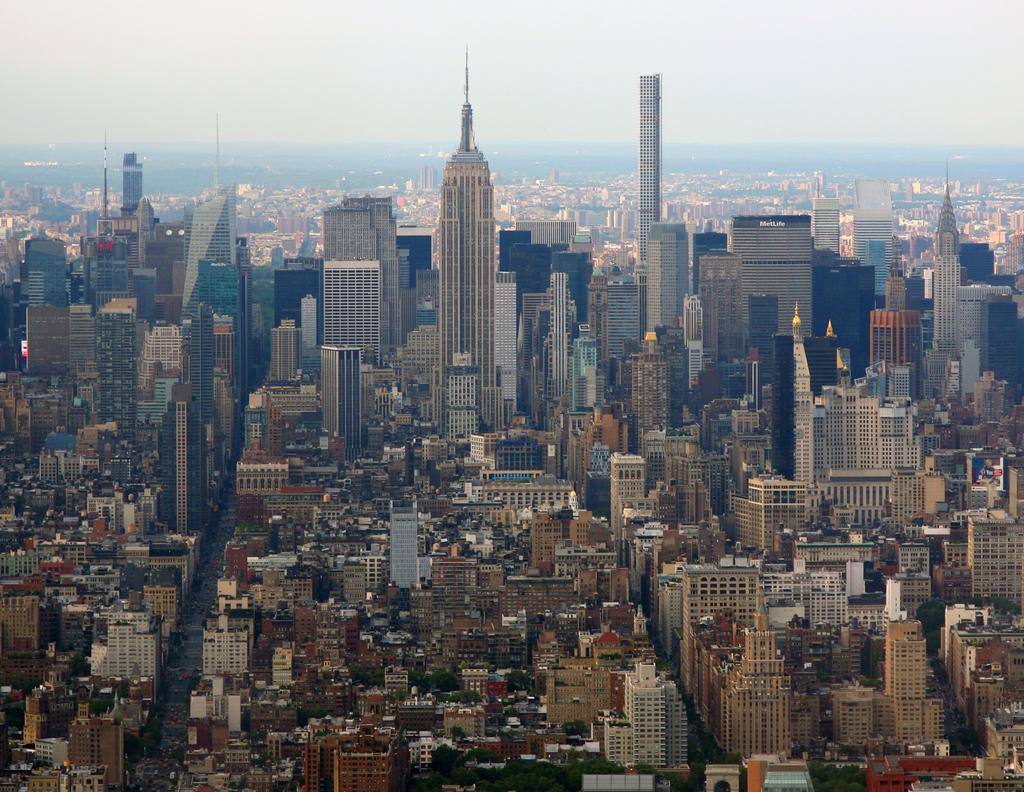Describe this image in one or two sentences. In this image I can see number of buildings. On the bottom side of this image I can see number of trees. 